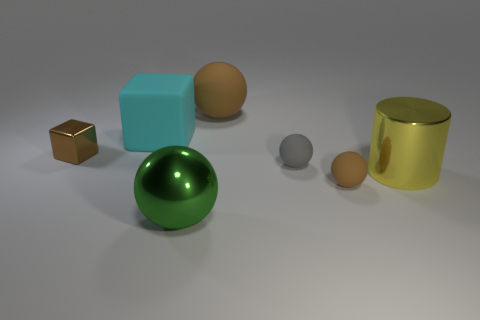There is a object that is both in front of the big yellow object and behind the large green metallic object; what is its size?
Your answer should be compact. Small. There is a small sphere that is in front of the tiny sphere behind the yellow thing; what number of shiny blocks are behind it?
Ensure brevity in your answer.  1. Is there another big rubber cube that has the same color as the large matte cube?
Your answer should be compact. No. What is the color of the cylinder that is the same size as the green object?
Give a very brief answer. Yellow. There is a tiny brown object behind the object to the right of the brown rubber object that is in front of the large yellow object; what is its shape?
Provide a short and direct response. Cube. What number of green metal things are right of the brown rubber object that is behind the brown shiny thing?
Your answer should be compact. 0. Do the big metallic object that is behind the tiny brown sphere and the large shiny thing that is to the left of the tiny brown ball have the same shape?
Ensure brevity in your answer.  No. There is a large green metallic ball; how many large shiny cylinders are behind it?
Provide a succinct answer. 1. Is the material of the small brown object in front of the yellow metal cylinder the same as the brown cube?
Offer a very short reply. No. The big metal object that is the same shape as the tiny gray matte object is what color?
Offer a terse response. Green. 